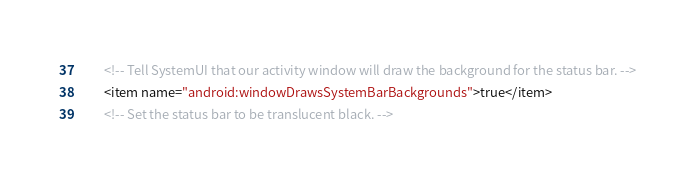Convert code to text. <code><loc_0><loc_0><loc_500><loc_500><_XML_>        <!-- Tell SystemUI that our activity window will draw the background for the status bar. -->
        <item name="android:windowDrawsSystemBarBackgrounds">true</item>
        <!-- Set the status bar to be translucent black. --></code> 